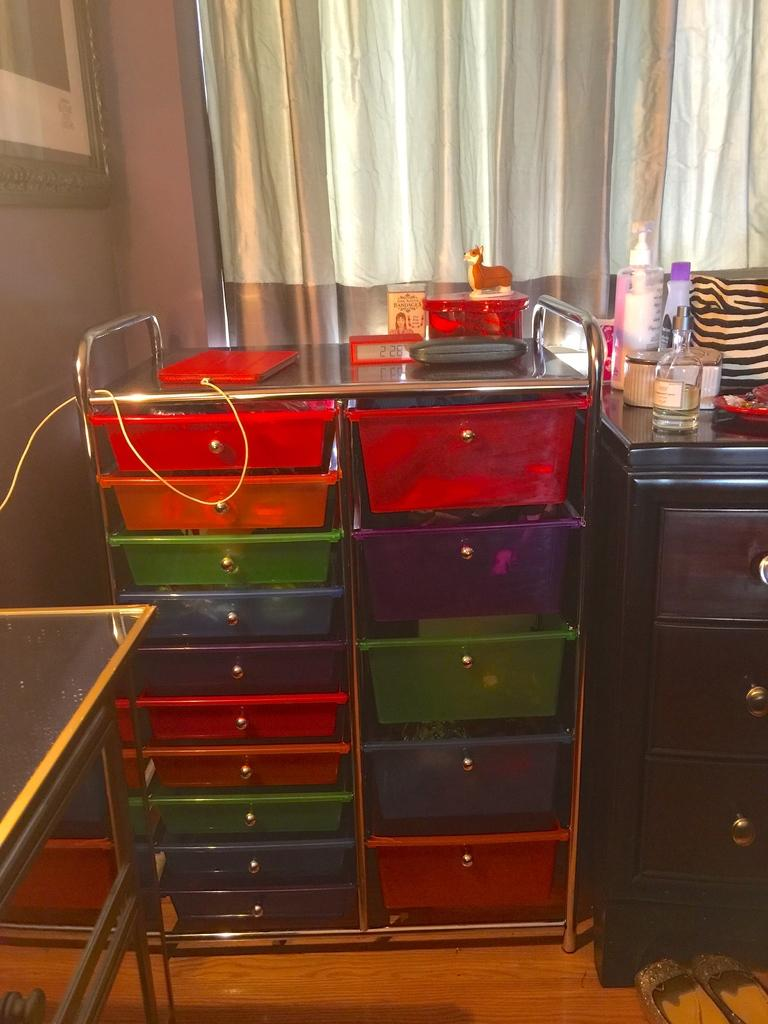What type of objects can be seen in the image? There are colorful trays in the image. How are the trays arranged in the image? The trays are placed in a rack. What type of books are placed on the shelf in the image? There is no shelf or books present in the image; it only features colorful trays placed in a rack. 